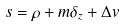Convert formula to latex. <formula><loc_0><loc_0><loc_500><loc_500>s = \rho + m \delta _ { z } + \Delta v</formula> 